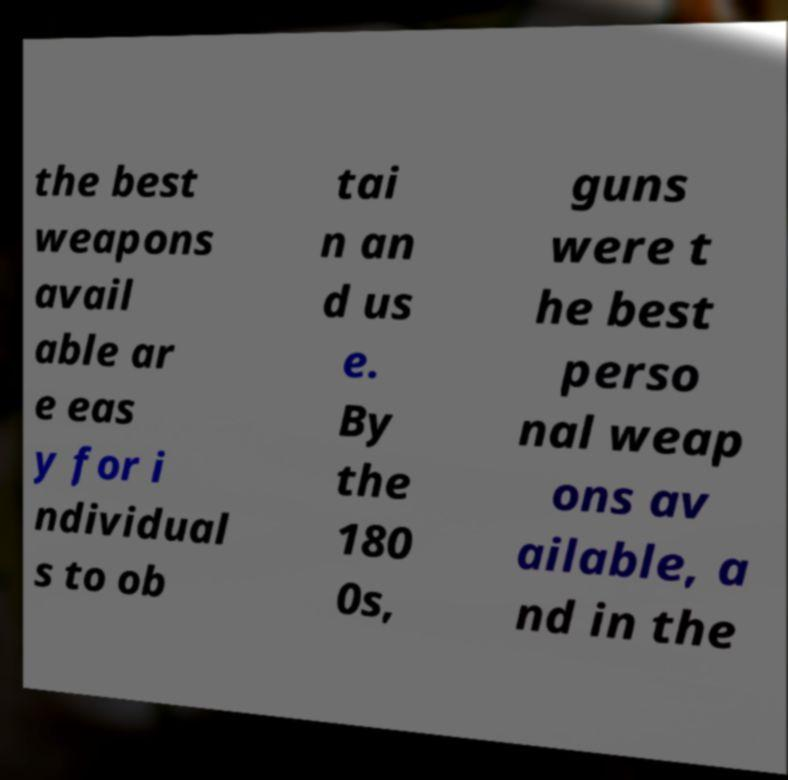There's text embedded in this image that I need extracted. Can you transcribe it verbatim? the best weapons avail able ar e eas y for i ndividual s to ob tai n an d us e. By the 180 0s, guns were t he best perso nal weap ons av ailable, a nd in the 